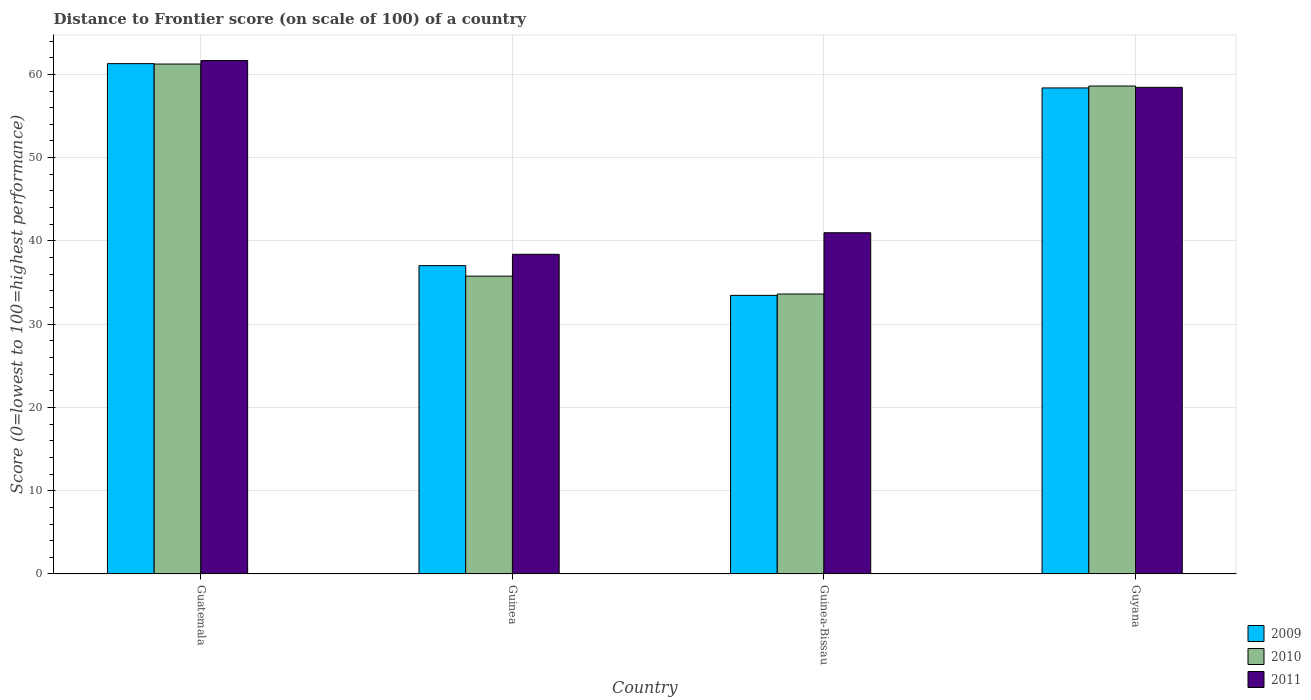How many groups of bars are there?
Your response must be concise. 4. Are the number of bars per tick equal to the number of legend labels?
Provide a succinct answer. Yes. How many bars are there on the 3rd tick from the right?
Your answer should be very brief. 3. What is the label of the 3rd group of bars from the left?
Your response must be concise. Guinea-Bissau. What is the distance to frontier score of in 2011 in Guatemala?
Give a very brief answer. 61.66. Across all countries, what is the maximum distance to frontier score of in 2009?
Offer a terse response. 61.29. Across all countries, what is the minimum distance to frontier score of in 2009?
Provide a short and direct response. 33.46. In which country was the distance to frontier score of in 2011 maximum?
Your answer should be very brief. Guatemala. In which country was the distance to frontier score of in 2009 minimum?
Ensure brevity in your answer.  Guinea-Bissau. What is the total distance to frontier score of in 2011 in the graph?
Make the answer very short. 199.47. What is the difference between the distance to frontier score of in 2010 in Guinea-Bissau and that in Guyana?
Your answer should be very brief. -24.98. What is the difference between the distance to frontier score of in 2009 in Guatemala and the distance to frontier score of in 2011 in Guyana?
Make the answer very short. 2.85. What is the average distance to frontier score of in 2009 per country?
Make the answer very short. 47.54. What is the difference between the distance to frontier score of of/in 2011 and distance to frontier score of of/in 2009 in Guinea?
Ensure brevity in your answer.  1.36. What is the ratio of the distance to frontier score of in 2010 in Guatemala to that in Guinea?
Provide a short and direct response. 1.71. Is the difference between the distance to frontier score of in 2011 in Guatemala and Guinea greater than the difference between the distance to frontier score of in 2009 in Guatemala and Guinea?
Make the answer very short. No. What is the difference between the highest and the second highest distance to frontier score of in 2009?
Your answer should be compact. 21.34. What is the difference between the highest and the lowest distance to frontier score of in 2011?
Give a very brief answer. 23.27. In how many countries, is the distance to frontier score of in 2010 greater than the average distance to frontier score of in 2010 taken over all countries?
Provide a short and direct response. 2. What does the 1st bar from the right in Guatemala represents?
Give a very brief answer. 2011. Is it the case that in every country, the sum of the distance to frontier score of in 2010 and distance to frontier score of in 2011 is greater than the distance to frontier score of in 2009?
Ensure brevity in your answer.  Yes. How many bars are there?
Your answer should be compact. 12. Are all the bars in the graph horizontal?
Offer a very short reply. No. How many countries are there in the graph?
Your response must be concise. 4. What is the difference between two consecutive major ticks on the Y-axis?
Offer a terse response. 10. Are the values on the major ticks of Y-axis written in scientific E-notation?
Provide a succinct answer. No. Does the graph contain any zero values?
Offer a very short reply. No. Where does the legend appear in the graph?
Give a very brief answer. Bottom right. How many legend labels are there?
Make the answer very short. 3. How are the legend labels stacked?
Your response must be concise. Vertical. What is the title of the graph?
Provide a short and direct response. Distance to Frontier score (on scale of 100) of a country. What is the label or title of the X-axis?
Provide a succinct answer. Country. What is the label or title of the Y-axis?
Your answer should be very brief. Score (0=lowest to 100=highest performance). What is the Score (0=lowest to 100=highest performance) of 2009 in Guatemala?
Keep it short and to the point. 61.29. What is the Score (0=lowest to 100=highest performance) of 2010 in Guatemala?
Offer a very short reply. 61.24. What is the Score (0=lowest to 100=highest performance) of 2011 in Guatemala?
Provide a short and direct response. 61.66. What is the Score (0=lowest to 100=highest performance) in 2009 in Guinea?
Provide a short and direct response. 37.03. What is the Score (0=lowest to 100=highest performance) of 2010 in Guinea?
Give a very brief answer. 35.77. What is the Score (0=lowest to 100=highest performance) of 2011 in Guinea?
Keep it short and to the point. 38.39. What is the Score (0=lowest to 100=highest performance) in 2009 in Guinea-Bissau?
Provide a short and direct response. 33.46. What is the Score (0=lowest to 100=highest performance) of 2010 in Guinea-Bissau?
Your answer should be very brief. 33.62. What is the Score (0=lowest to 100=highest performance) in 2011 in Guinea-Bissau?
Keep it short and to the point. 40.98. What is the Score (0=lowest to 100=highest performance) in 2009 in Guyana?
Your answer should be very brief. 58.37. What is the Score (0=lowest to 100=highest performance) in 2010 in Guyana?
Your answer should be compact. 58.6. What is the Score (0=lowest to 100=highest performance) in 2011 in Guyana?
Make the answer very short. 58.44. Across all countries, what is the maximum Score (0=lowest to 100=highest performance) of 2009?
Keep it short and to the point. 61.29. Across all countries, what is the maximum Score (0=lowest to 100=highest performance) of 2010?
Make the answer very short. 61.24. Across all countries, what is the maximum Score (0=lowest to 100=highest performance) in 2011?
Make the answer very short. 61.66. Across all countries, what is the minimum Score (0=lowest to 100=highest performance) in 2009?
Your answer should be very brief. 33.46. Across all countries, what is the minimum Score (0=lowest to 100=highest performance) of 2010?
Offer a terse response. 33.62. Across all countries, what is the minimum Score (0=lowest to 100=highest performance) in 2011?
Your answer should be very brief. 38.39. What is the total Score (0=lowest to 100=highest performance) in 2009 in the graph?
Your answer should be compact. 190.15. What is the total Score (0=lowest to 100=highest performance) of 2010 in the graph?
Provide a succinct answer. 189.23. What is the total Score (0=lowest to 100=highest performance) in 2011 in the graph?
Offer a very short reply. 199.47. What is the difference between the Score (0=lowest to 100=highest performance) in 2009 in Guatemala and that in Guinea?
Make the answer very short. 24.26. What is the difference between the Score (0=lowest to 100=highest performance) in 2010 in Guatemala and that in Guinea?
Keep it short and to the point. 25.47. What is the difference between the Score (0=lowest to 100=highest performance) in 2011 in Guatemala and that in Guinea?
Provide a succinct answer. 23.27. What is the difference between the Score (0=lowest to 100=highest performance) of 2009 in Guatemala and that in Guinea-Bissau?
Offer a terse response. 27.83. What is the difference between the Score (0=lowest to 100=highest performance) of 2010 in Guatemala and that in Guinea-Bissau?
Give a very brief answer. 27.62. What is the difference between the Score (0=lowest to 100=highest performance) in 2011 in Guatemala and that in Guinea-Bissau?
Make the answer very short. 20.68. What is the difference between the Score (0=lowest to 100=highest performance) of 2009 in Guatemala and that in Guyana?
Keep it short and to the point. 2.92. What is the difference between the Score (0=lowest to 100=highest performance) of 2010 in Guatemala and that in Guyana?
Keep it short and to the point. 2.64. What is the difference between the Score (0=lowest to 100=highest performance) of 2011 in Guatemala and that in Guyana?
Offer a very short reply. 3.22. What is the difference between the Score (0=lowest to 100=highest performance) in 2009 in Guinea and that in Guinea-Bissau?
Your response must be concise. 3.57. What is the difference between the Score (0=lowest to 100=highest performance) of 2010 in Guinea and that in Guinea-Bissau?
Provide a succinct answer. 2.15. What is the difference between the Score (0=lowest to 100=highest performance) in 2011 in Guinea and that in Guinea-Bissau?
Provide a short and direct response. -2.59. What is the difference between the Score (0=lowest to 100=highest performance) of 2009 in Guinea and that in Guyana?
Keep it short and to the point. -21.34. What is the difference between the Score (0=lowest to 100=highest performance) of 2010 in Guinea and that in Guyana?
Provide a succinct answer. -22.83. What is the difference between the Score (0=lowest to 100=highest performance) in 2011 in Guinea and that in Guyana?
Make the answer very short. -20.05. What is the difference between the Score (0=lowest to 100=highest performance) of 2009 in Guinea-Bissau and that in Guyana?
Your response must be concise. -24.91. What is the difference between the Score (0=lowest to 100=highest performance) in 2010 in Guinea-Bissau and that in Guyana?
Your answer should be very brief. -24.98. What is the difference between the Score (0=lowest to 100=highest performance) of 2011 in Guinea-Bissau and that in Guyana?
Provide a succinct answer. -17.46. What is the difference between the Score (0=lowest to 100=highest performance) in 2009 in Guatemala and the Score (0=lowest to 100=highest performance) in 2010 in Guinea?
Your answer should be very brief. 25.52. What is the difference between the Score (0=lowest to 100=highest performance) in 2009 in Guatemala and the Score (0=lowest to 100=highest performance) in 2011 in Guinea?
Your answer should be very brief. 22.9. What is the difference between the Score (0=lowest to 100=highest performance) in 2010 in Guatemala and the Score (0=lowest to 100=highest performance) in 2011 in Guinea?
Provide a short and direct response. 22.85. What is the difference between the Score (0=lowest to 100=highest performance) of 2009 in Guatemala and the Score (0=lowest to 100=highest performance) of 2010 in Guinea-Bissau?
Your answer should be very brief. 27.67. What is the difference between the Score (0=lowest to 100=highest performance) in 2009 in Guatemala and the Score (0=lowest to 100=highest performance) in 2011 in Guinea-Bissau?
Provide a short and direct response. 20.31. What is the difference between the Score (0=lowest to 100=highest performance) in 2010 in Guatemala and the Score (0=lowest to 100=highest performance) in 2011 in Guinea-Bissau?
Provide a succinct answer. 20.26. What is the difference between the Score (0=lowest to 100=highest performance) in 2009 in Guatemala and the Score (0=lowest to 100=highest performance) in 2010 in Guyana?
Provide a succinct answer. 2.69. What is the difference between the Score (0=lowest to 100=highest performance) of 2009 in Guatemala and the Score (0=lowest to 100=highest performance) of 2011 in Guyana?
Your answer should be very brief. 2.85. What is the difference between the Score (0=lowest to 100=highest performance) of 2010 in Guatemala and the Score (0=lowest to 100=highest performance) of 2011 in Guyana?
Your answer should be very brief. 2.8. What is the difference between the Score (0=lowest to 100=highest performance) of 2009 in Guinea and the Score (0=lowest to 100=highest performance) of 2010 in Guinea-Bissau?
Keep it short and to the point. 3.41. What is the difference between the Score (0=lowest to 100=highest performance) of 2009 in Guinea and the Score (0=lowest to 100=highest performance) of 2011 in Guinea-Bissau?
Your response must be concise. -3.95. What is the difference between the Score (0=lowest to 100=highest performance) in 2010 in Guinea and the Score (0=lowest to 100=highest performance) in 2011 in Guinea-Bissau?
Your answer should be very brief. -5.21. What is the difference between the Score (0=lowest to 100=highest performance) of 2009 in Guinea and the Score (0=lowest to 100=highest performance) of 2010 in Guyana?
Your answer should be compact. -21.57. What is the difference between the Score (0=lowest to 100=highest performance) of 2009 in Guinea and the Score (0=lowest to 100=highest performance) of 2011 in Guyana?
Your answer should be compact. -21.41. What is the difference between the Score (0=lowest to 100=highest performance) in 2010 in Guinea and the Score (0=lowest to 100=highest performance) in 2011 in Guyana?
Provide a short and direct response. -22.67. What is the difference between the Score (0=lowest to 100=highest performance) in 2009 in Guinea-Bissau and the Score (0=lowest to 100=highest performance) in 2010 in Guyana?
Keep it short and to the point. -25.14. What is the difference between the Score (0=lowest to 100=highest performance) in 2009 in Guinea-Bissau and the Score (0=lowest to 100=highest performance) in 2011 in Guyana?
Offer a terse response. -24.98. What is the difference between the Score (0=lowest to 100=highest performance) of 2010 in Guinea-Bissau and the Score (0=lowest to 100=highest performance) of 2011 in Guyana?
Offer a very short reply. -24.82. What is the average Score (0=lowest to 100=highest performance) of 2009 per country?
Your answer should be compact. 47.54. What is the average Score (0=lowest to 100=highest performance) in 2010 per country?
Make the answer very short. 47.31. What is the average Score (0=lowest to 100=highest performance) of 2011 per country?
Your response must be concise. 49.87. What is the difference between the Score (0=lowest to 100=highest performance) of 2009 and Score (0=lowest to 100=highest performance) of 2010 in Guatemala?
Make the answer very short. 0.05. What is the difference between the Score (0=lowest to 100=highest performance) in 2009 and Score (0=lowest to 100=highest performance) in 2011 in Guatemala?
Your answer should be compact. -0.37. What is the difference between the Score (0=lowest to 100=highest performance) in 2010 and Score (0=lowest to 100=highest performance) in 2011 in Guatemala?
Provide a succinct answer. -0.42. What is the difference between the Score (0=lowest to 100=highest performance) of 2009 and Score (0=lowest to 100=highest performance) of 2010 in Guinea?
Give a very brief answer. 1.26. What is the difference between the Score (0=lowest to 100=highest performance) of 2009 and Score (0=lowest to 100=highest performance) of 2011 in Guinea?
Ensure brevity in your answer.  -1.36. What is the difference between the Score (0=lowest to 100=highest performance) in 2010 and Score (0=lowest to 100=highest performance) in 2011 in Guinea?
Provide a succinct answer. -2.62. What is the difference between the Score (0=lowest to 100=highest performance) in 2009 and Score (0=lowest to 100=highest performance) in 2010 in Guinea-Bissau?
Your response must be concise. -0.16. What is the difference between the Score (0=lowest to 100=highest performance) in 2009 and Score (0=lowest to 100=highest performance) in 2011 in Guinea-Bissau?
Give a very brief answer. -7.52. What is the difference between the Score (0=lowest to 100=highest performance) of 2010 and Score (0=lowest to 100=highest performance) of 2011 in Guinea-Bissau?
Your response must be concise. -7.36. What is the difference between the Score (0=lowest to 100=highest performance) in 2009 and Score (0=lowest to 100=highest performance) in 2010 in Guyana?
Provide a succinct answer. -0.23. What is the difference between the Score (0=lowest to 100=highest performance) in 2009 and Score (0=lowest to 100=highest performance) in 2011 in Guyana?
Your answer should be very brief. -0.07. What is the difference between the Score (0=lowest to 100=highest performance) of 2010 and Score (0=lowest to 100=highest performance) of 2011 in Guyana?
Give a very brief answer. 0.16. What is the ratio of the Score (0=lowest to 100=highest performance) of 2009 in Guatemala to that in Guinea?
Provide a succinct answer. 1.66. What is the ratio of the Score (0=lowest to 100=highest performance) of 2010 in Guatemala to that in Guinea?
Give a very brief answer. 1.71. What is the ratio of the Score (0=lowest to 100=highest performance) of 2011 in Guatemala to that in Guinea?
Your answer should be compact. 1.61. What is the ratio of the Score (0=lowest to 100=highest performance) in 2009 in Guatemala to that in Guinea-Bissau?
Ensure brevity in your answer.  1.83. What is the ratio of the Score (0=lowest to 100=highest performance) in 2010 in Guatemala to that in Guinea-Bissau?
Offer a terse response. 1.82. What is the ratio of the Score (0=lowest to 100=highest performance) in 2011 in Guatemala to that in Guinea-Bissau?
Your answer should be compact. 1.5. What is the ratio of the Score (0=lowest to 100=highest performance) in 2010 in Guatemala to that in Guyana?
Your response must be concise. 1.05. What is the ratio of the Score (0=lowest to 100=highest performance) of 2011 in Guatemala to that in Guyana?
Offer a very short reply. 1.06. What is the ratio of the Score (0=lowest to 100=highest performance) of 2009 in Guinea to that in Guinea-Bissau?
Ensure brevity in your answer.  1.11. What is the ratio of the Score (0=lowest to 100=highest performance) of 2010 in Guinea to that in Guinea-Bissau?
Offer a terse response. 1.06. What is the ratio of the Score (0=lowest to 100=highest performance) in 2011 in Guinea to that in Guinea-Bissau?
Keep it short and to the point. 0.94. What is the ratio of the Score (0=lowest to 100=highest performance) in 2009 in Guinea to that in Guyana?
Your answer should be very brief. 0.63. What is the ratio of the Score (0=lowest to 100=highest performance) in 2010 in Guinea to that in Guyana?
Your response must be concise. 0.61. What is the ratio of the Score (0=lowest to 100=highest performance) of 2011 in Guinea to that in Guyana?
Your answer should be compact. 0.66. What is the ratio of the Score (0=lowest to 100=highest performance) of 2009 in Guinea-Bissau to that in Guyana?
Ensure brevity in your answer.  0.57. What is the ratio of the Score (0=lowest to 100=highest performance) of 2010 in Guinea-Bissau to that in Guyana?
Keep it short and to the point. 0.57. What is the ratio of the Score (0=lowest to 100=highest performance) of 2011 in Guinea-Bissau to that in Guyana?
Give a very brief answer. 0.7. What is the difference between the highest and the second highest Score (0=lowest to 100=highest performance) of 2009?
Your answer should be very brief. 2.92. What is the difference between the highest and the second highest Score (0=lowest to 100=highest performance) of 2010?
Give a very brief answer. 2.64. What is the difference between the highest and the second highest Score (0=lowest to 100=highest performance) of 2011?
Offer a very short reply. 3.22. What is the difference between the highest and the lowest Score (0=lowest to 100=highest performance) of 2009?
Ensure brevity in your answer.  27.83. What is the difference between the highest and the lowest Score (0=lowest to 100=highest performance) of 2010?
Keep it short and to the point. 27.62. What is the difference between the highest and the lowest Score (0=lowest to 100=highest performance) of 2011?
Provide a short and direct response. 23.27. 